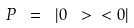Convert formula to latex. <formula><loc_0><loc_0><loc_500><loc_500>P \ = \ | 0 \ > \ < 0 |</formula> 